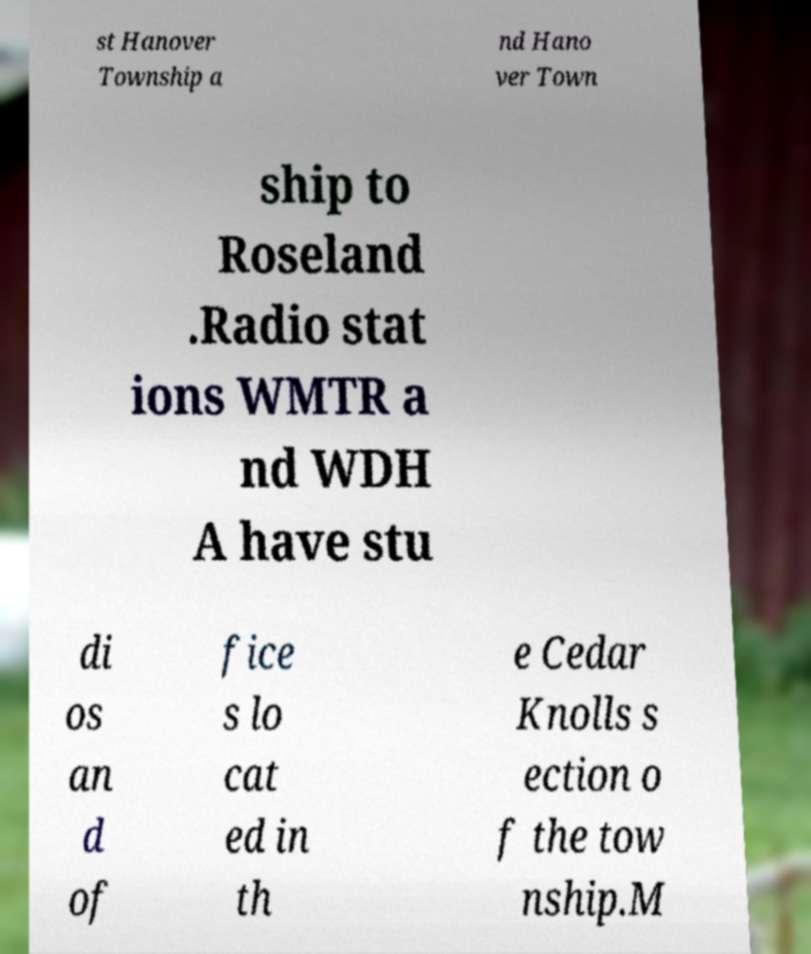Can you read and provide the text displayed in the image?This photo seems to have some interesting text. Can you extract and type it out for me? st Hanover Township a nd Hano ver Town ship to Roseland .Radio stat ions WMTR a nd WDH A have stu di os an d of fice s lo cat ed in th e Cedar Knolls s ection o f the tow nship.M 